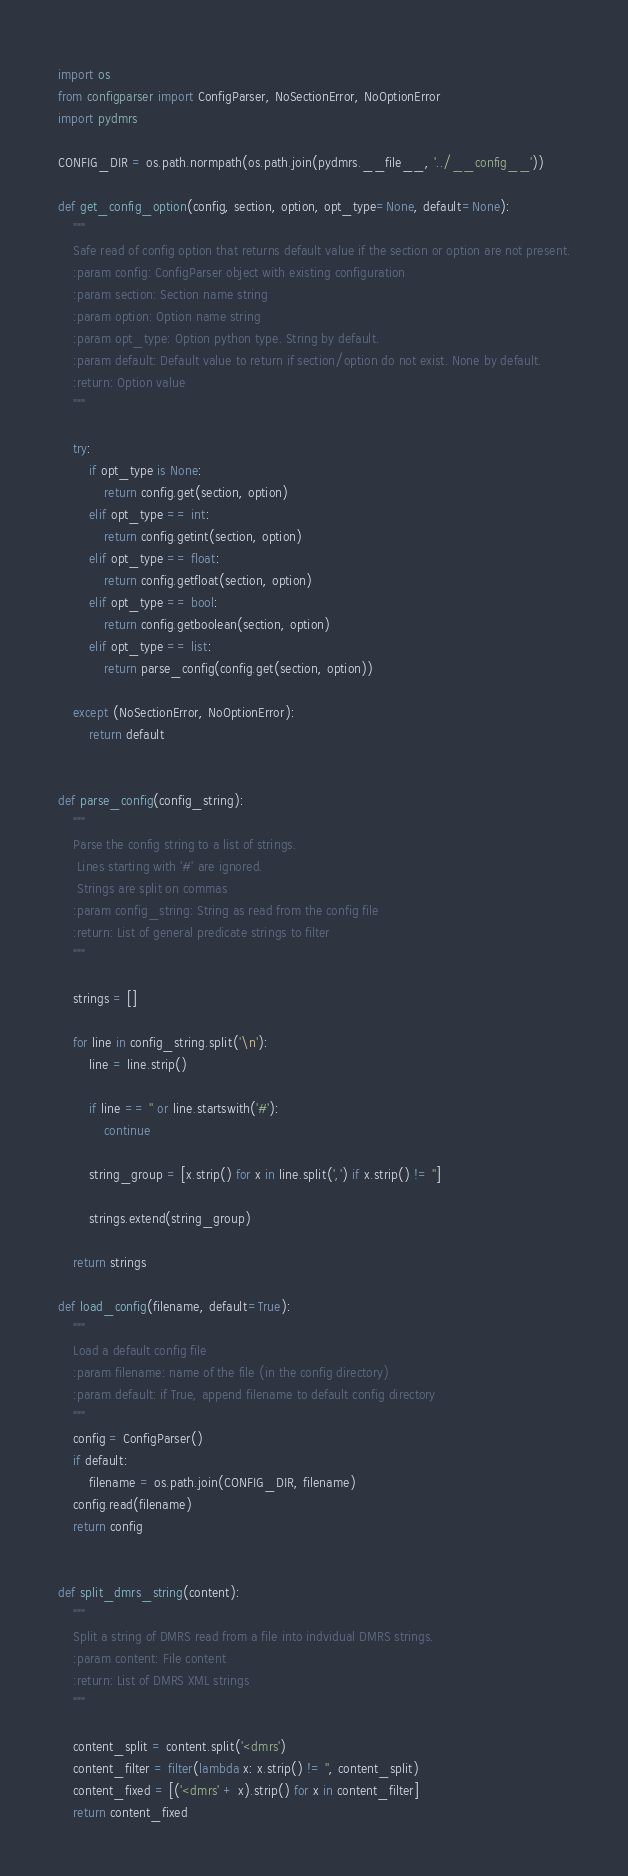<code> <loc_0><loc_0><loc_500><loc_500><_Python_>import os
from configparser import ConfigParser, NoSectionError, NoOptionError
import pydmrs

CONFIG_DIR = os.path.normpath(os.path.join(pydmrs.__file__, '../__config__'))

def get_config_option(config, section, option, opt_type=None, default=None):
    """
    Safe read of config option that returns default value if the section or option are not present.
    :param config: ConfigParser object with existing configuration
    :param section: Section name string
    :param option: Option name string
    :param opt_type: Option python type. String by default.
    :param default: Default value to return if section/option do not exist. None by default.
    :return: Option value
    """

    try:
        if opt_type is None:
            return config.get(section, option)
        elif opt_type == int:
            return config.getint(section, option)
        elif opt_type == float:
            return config.getfloat(section, option)
        elif opt_type == bool:
            return config.getboolean(section, option)
        elif opt_type == list:
            return parse_config(config.get(section, option))

    except (NoSectionError, NoOptionError):
        return default


def parse_config(config_string):
    """
    Parse the config string to a list of strings.
     Lines starting with '#' are ignored.
     Strings are split on commas
    :param config_string: String as read from the config file
    :return: List of general predicate strings to filter
    """

    strings = []

    for line in config_string.split('\n'):
        line = line.strip()

        if line == '' or line.startswith('#'):
            continue

        string_group = [x.strip() for x in line.split(',') if x.strip() != '']

        strings.extend(string_group)

    return strings

def load_config(filename, default=True):
    """
    Load a default config file
    :param filename: name of the file (in the config directory)
    :param default: if True, append filename to default config directory
    """
    config = ConfigParser()
    if default:
        filename = os.path.join(CONFIG_DIR, filename) 
    config.read(filename)
    return config


def split_dmrs_string(content):
    """
    Split a string of DMRS read from a file into indvidual DMRS strings.
    :param content: File content
    :return: List of DMRS XML strings
    """

    content_split = content.split('<dmrs')
    content_filter = filter(lambda x: x.strip() != '', content_split)
    content_fixed = [('<dmrs' + x).strip() for x in content_filter]
    return content_fixed</code> 